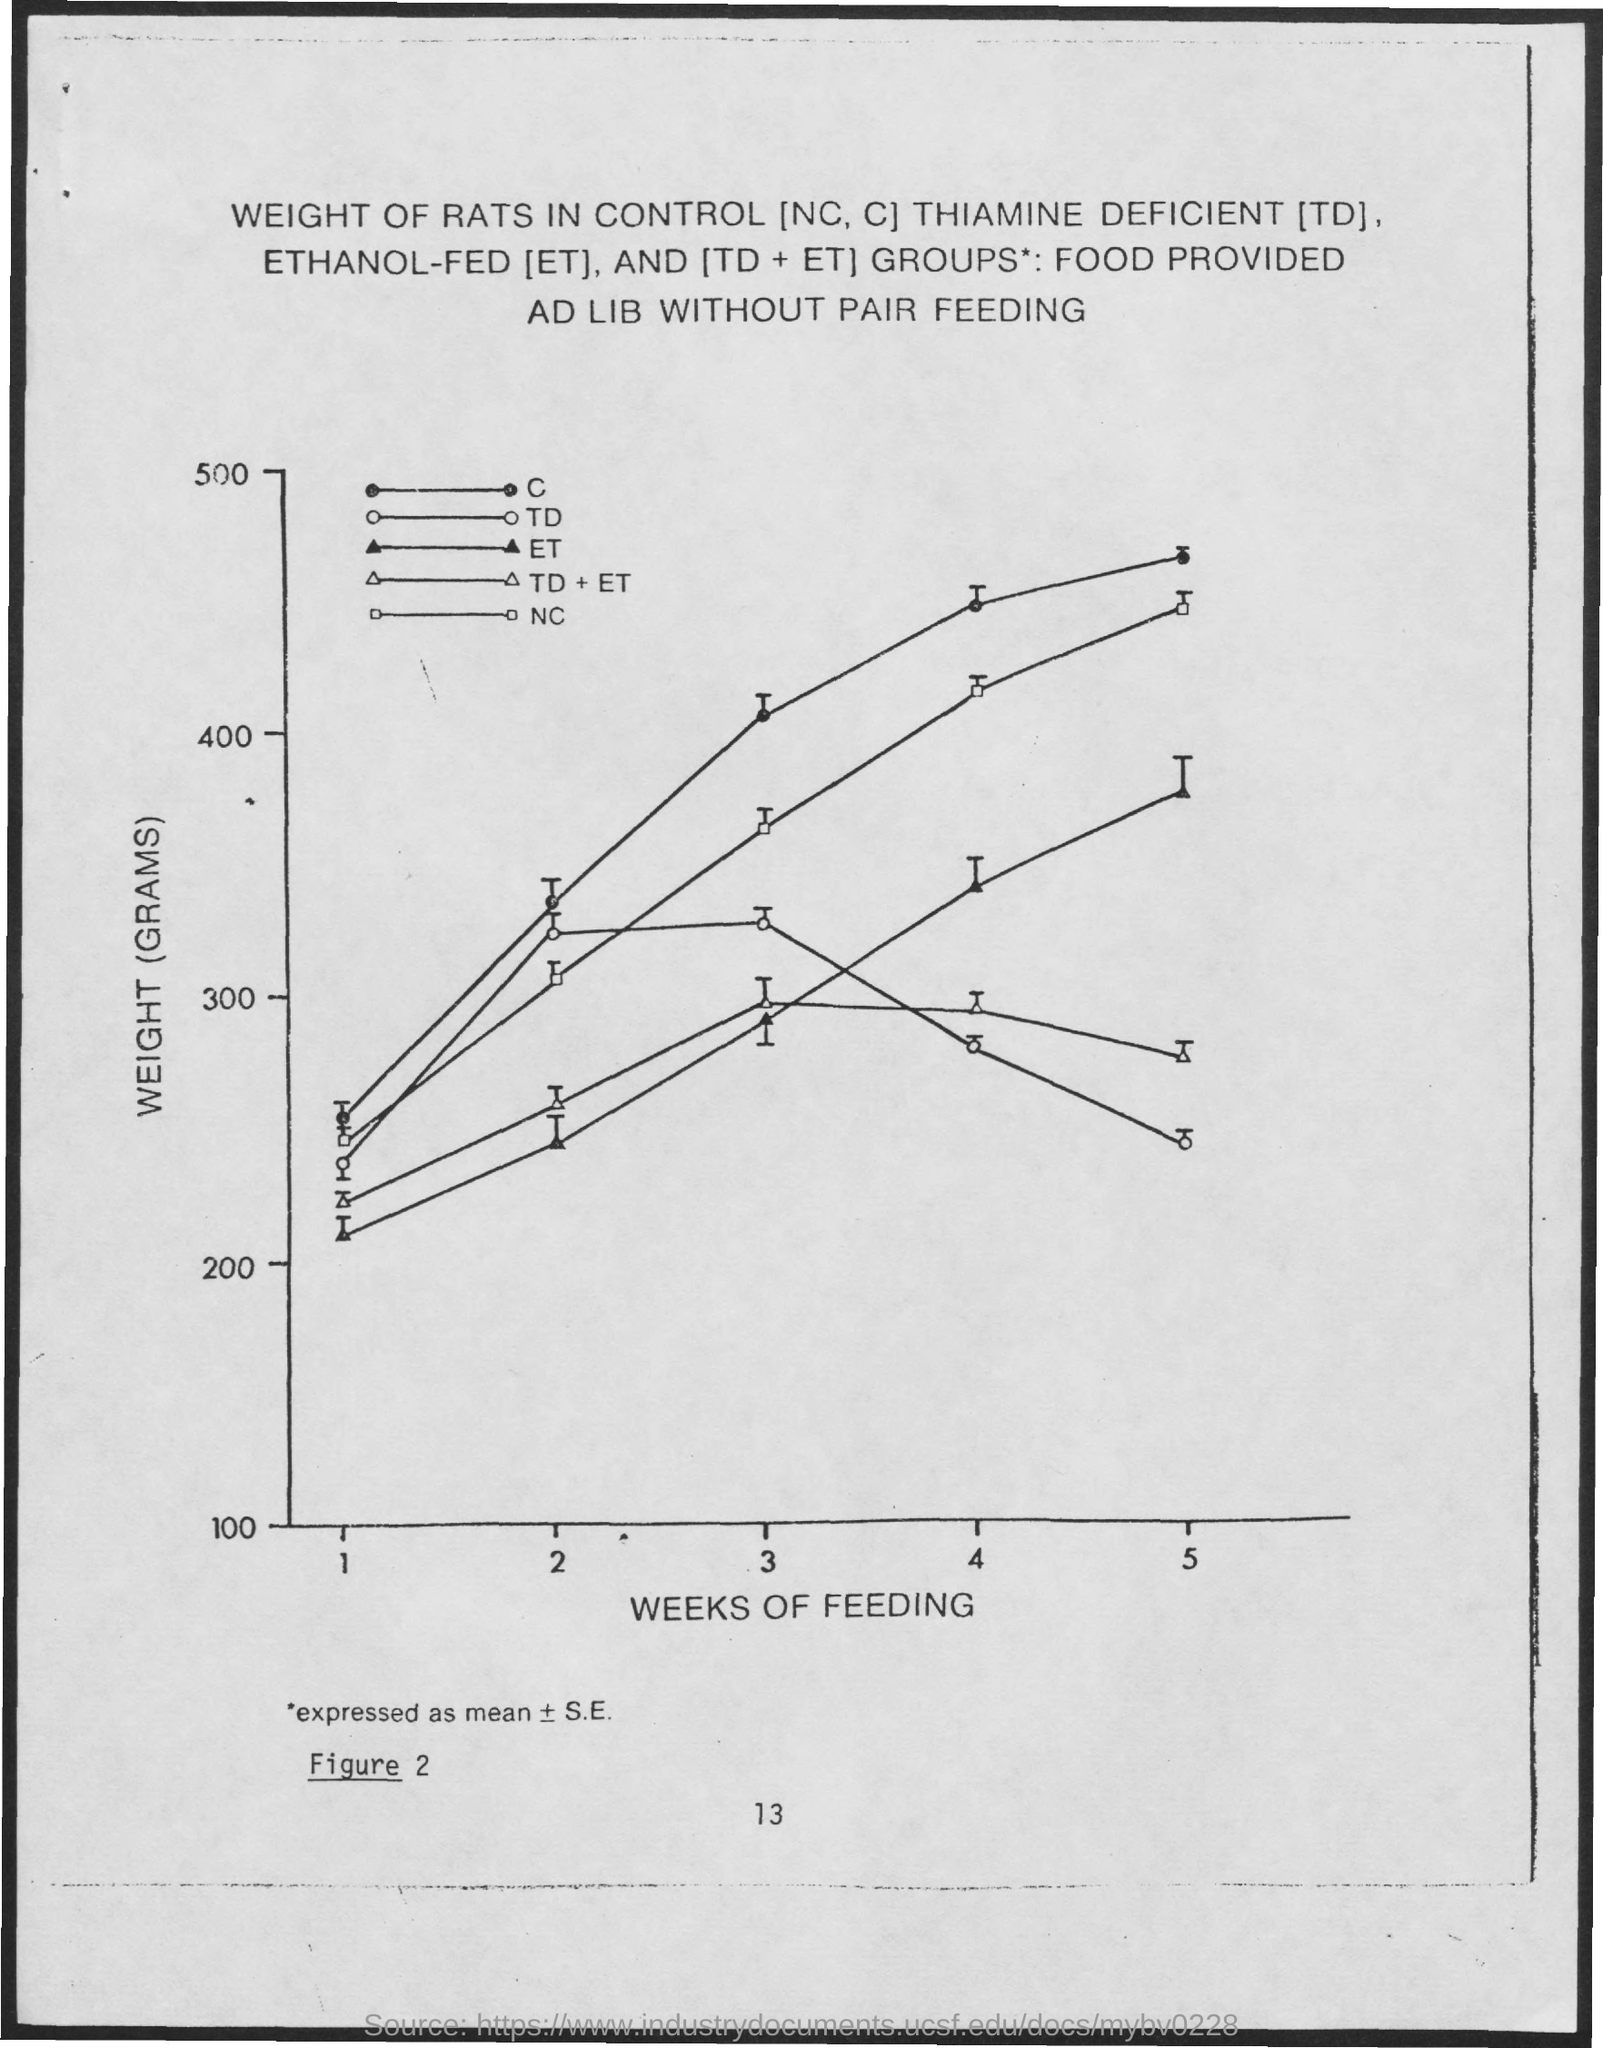What is the x-axis?
Your response must be concise. Weeks of feeding. What is the y-axis?
Ensure brevity in your answer.  Weight (grams). What does td stand for?
Offer a very short reply. Thiamine deficient. 